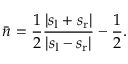Convert formula to latex. <formula><loc_0><loc_0><loc_500><loc_500>\bar { n } = \frac { 1 } { 2 } \frac { | s _ { l } + s _ { r } | } { | s _ { l } - s _ { r } | } - \frac { 1 } { 2 } .</formula> 